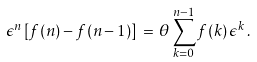<formula> <loc_0><loc_0><loc_500><loc_500>\epsilon ^ { n } \, [ f ( n ) - f ( n - 1 ) ] \, = \, \theta \sum _ { k = 0 } ^ { n - 1 } f ( k ) \, \epsilon ^ { k } \, .</formula> 